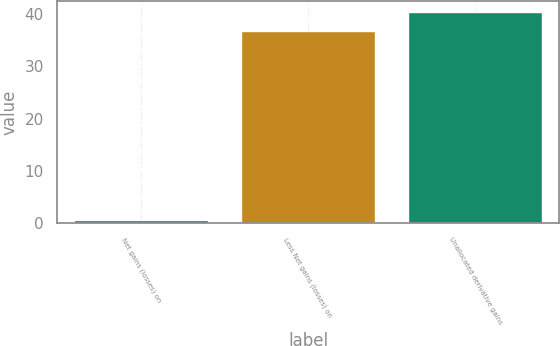<chart> <loc_0><loc_0><loc_500><loc_500><bar_chart><fcel>Net gains (losses) on<fcel>Less Net gains (losses) on<fcel>Unallocated derivative gains<nl><fcel>0.6<fcel>36.7<fcel>40.37<nl></chart> 